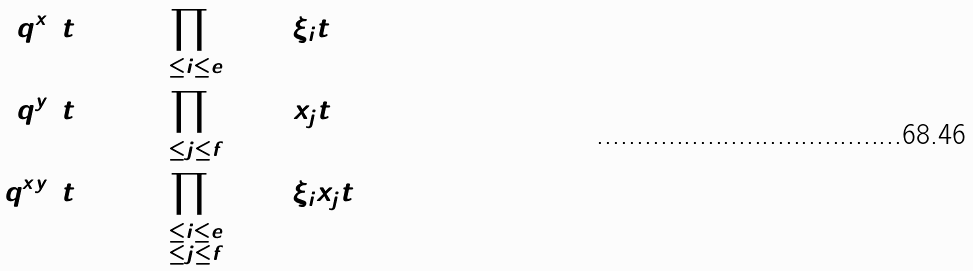<formula> <loc_0><loc_0><loc_500><loc_500>q ^ { x } ( t ) & \colon = \prod _ { 1 \leq i \leq e } ( 1 + \xi _ { i } t ) \\ q ^ { y } ( t ) & \colon = \prod _ { 1 \leq j \leq f } ( 1 + x _ { j } t ) \\ q ^ { x y } ( t ) & \colon = \prod _ { \substack { 1 \leq i \leq e \\ 1 \leq j \leq f } } ( 1 + \xi _ { i } x _ { j } t ) \\</formula> 